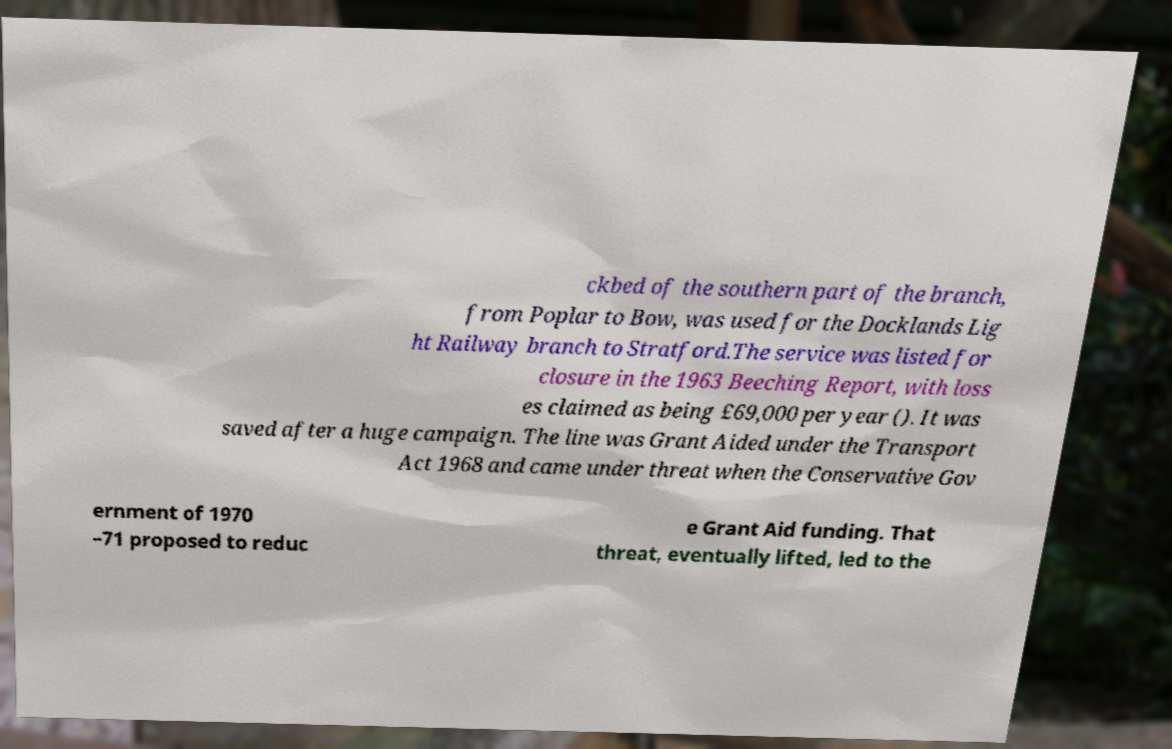For documentation purposes, I need the text within this image transcribed. Could you provide that? ckbed of the southern part of the branch, from Poplar to Bow, was used for the Docklands Lig ht Railway branch to Stratford.The service was listed for closure in the 1963 Beeching Report, with loss es claimed as being £69,000 per year (). It was saved after a huge campaign. The line was Grant Aided under the Transport Act 1968 and came under threat when the Conservative Gov ernment of 1970 –71 proposed to reduc e Grant Aid funding. That threat, eventually lifted, led to the 